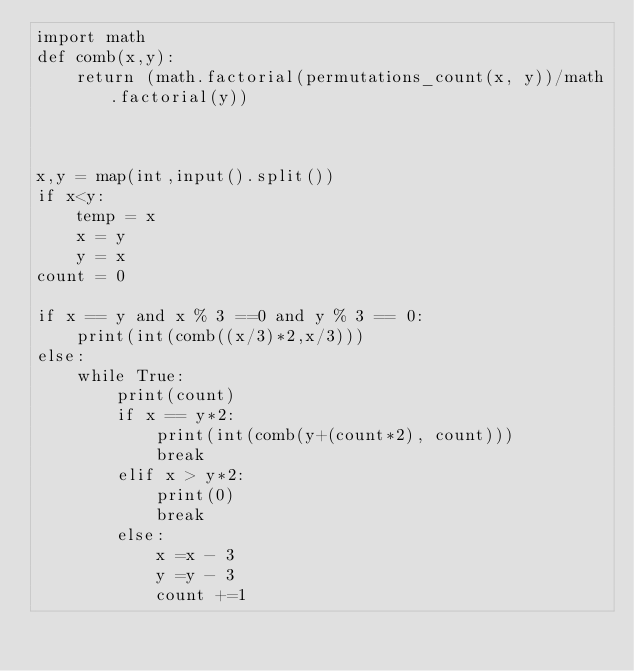Convert code to text. <code><loc_0><loc_0><loc_500><loc_500><_Python_>import math
def comb(x,y):
    return (math.factorial(permutations_count(x, y))/math.factorial(y))



x,y = map(int,input().split())
if x<y:
    temp = x
    x = y
    y = x
count = 0

if x == y and x % 3 ==0 and y % 3 == 0:
    print(int(comb((x/3)*2,x/3)))
else:
    while True:
        print(count)
        if x == y*2:
            print(int(comb(y+(count*2), count)))
            break
        elif x > y*2:
            print(0)
            break
        else:
            x =x - 3
            y =y - 3
            count +=1
</code> 